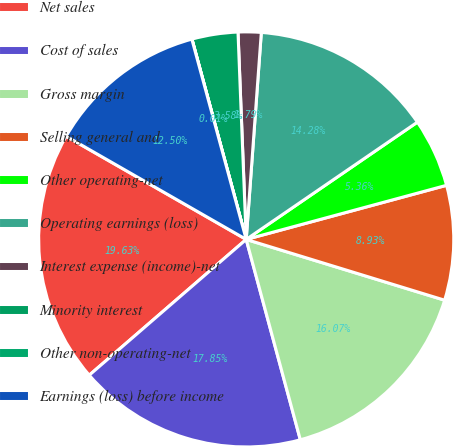Convert chart. <chart><loc_0><loc_0><loc_500><loc_500><pie_chart><fcel>Net sales<fcel>Cost of sales<fcel>Gross margin<fcel>Selling general and<fcel>Other operating-net<fcel>Operating earnings (loss)<fcel>Interest expense (income)-net<fcel>Minority interest<fcel>Other non-operating-net<fcel>Earnings (loss) before income<nl><fcel>19.63%<fcel>17.85%<fcel>16.07%<fcel>8.93%<fcel>5.36%<fcel>14.28%<fcel>1.79%<fcel>3.58%<fcel>0.01%<fcel>12.5%<nl></chart> 